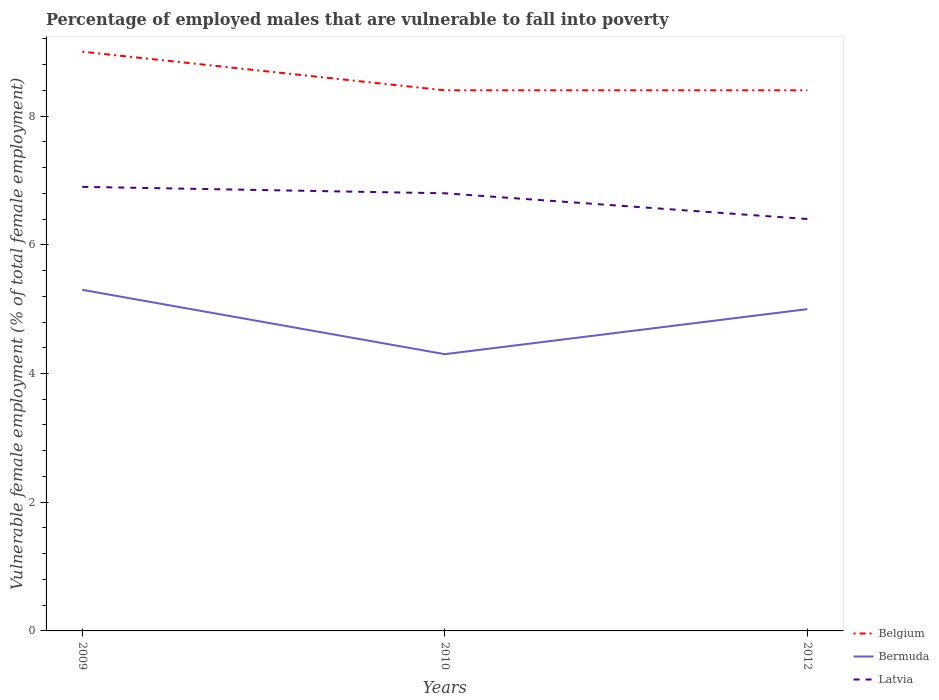Does the line corresponding to Bermuda intersect with the line corresponding to Latvia?
Provide a succinct answer. No. Is the number of lines equal to the number of legend labels?
Make the answer very short. Yes. Across all years, what is the maximum percentage of employed males who are vulnerable to fall into poverty in Bermuda?
Provide a succinct answer. 4.3. What is the total percentage of employed males who are vulnerable to fall into poverty in Bermuda in the graph?
Your answer should be compact. 1. What is the difference between the highest and the second highest percentage of employed males who are vulnerable to fall into poverty in Belgium?
Offer a terse response. 0.6. What is the difference between the highest and the lowest percentage of employed males who are vulnerable to fall into poverty in Bermuda?
Your answer should be compact. 2. Is the percentage of employed males who are vulnerable to fall into poverty in Bermuda strictly greater than the percentage of employed males who are vulnerable to fall into poverty in Belgium over the years?
Make the answer very short. Yes. How many lines are there?
Make the answer very short. 3. How many years are there in the graph?
Keep it short and to the point. 3. Are the values on the major ticks of Y-axis written in scientific E-notation?
Offer a very short reply. No. Where does the legend appear in the graph?
Your response must be concise. Bottom right. How many legend labels are there?
Make the answer very short. 3. What is the title of the graph?
Your response must be concise. Percentage of employed males that are vulnerable to fall into poverty. Does "Trinidad and Tobago" appear as one of the legend labels in the graph?
Offer a very short reply. No. What is the label or title of the Y-axis?
Offer a terse response. Vulnerable female employment (% of total female employment). What is the Vulnerable female employment (% of total female employment) in Bermuda in 2009?
Offer a very short reply. 5.3. What is the Vulnerable female employment (% of total female employment) in Latvia in 2009?
Your answer should be very brief. 6.9. What is the Vulnerable female employment (% of total female employment) of Belgium in 2010?
Make the answer very short. 8.4. What is the Vulnerable female employment (% of total female employment) in Bermuda in 2010?
Make the answer very short. 4.3. What is the Vulnerable female employment (% of total female employment) in Latvia in 2010?
Give a very brief answer. 6.8. What is the Vulnerable female employment (% of total female employment) of Belgium in 2012?
Make the answer very short. 8.4. What is the Vulnerable female employment (% of total female employment) in Latvia in 2012?
Offer a very short reply. 6.4. Across all years, what is the maximum Vulnerable female employment (% of total female employment) of Belgium?
Provide a short and direct response. 9. Across all years, what is the maximum Vulnerable female employment (% of total female employment) of Bermuda?
Your answer should be very brief. 5.3. Across all years, what is the maximum Vulnerable female employment (% of total female employment) in Latvia?
Keep it short and to the point. 6.9. Across all years, what is the minimum Vulnerable female employment (% of total female employment) in Belgium?
Ensure brevity in your answer.  8.4. Across all years, what is the minimum Vulnerable female employment (% of total female employment) in Bermuda?
Offer a terse response. 4.3. Across all years, what is the minimum Vulnerable female employment (% of total female employment) in Latvia?
Your answer should be very brief. 6.4. What is the total Vulnerable female employment (% of total female employment) in Belgium in the graph?
Keep it short and to the point. 25.8. What is the total Vulnerable female employment (% of total female employment) of Bermuda in the graph?
Your response must be concise. 14.6. What is the total Vulnerable female employment (% of total female employment) in Latvia in the graph?
Your answer should be very brief. 20.1. What is the difference between the Vulnerable female employment (% of total female employment) in Latvia in 2009 and that in 2010?
Make the answer very short. 0.1. What is the difference between the Vulnerable female employment (% of total female employment) in Belgium in 2009 and that in 2012?
Your response must be concise. 0.6. What is the difference between the Vulnerable female employment (% of total female employment) in Bermuda in 2009 and that in 2012?
Your answer should be compact. 0.3. What is the difference between the Vulnerable female employment (% of total female employment) of Latvia in 2009 and that in 2012?
Provide a short and direct response. 0.5. What is the difference between the Vulnerable female employment (% of total female employment) in Belgium in 2010 and that in 2012?
Keep it short and to the point. 0. What is the difference between the Vulnerable female employment (% of total female employment) of Bermuda in 2010 and that in 2012?
Give a very brief answer. -0.7. What is the difference between the Vulnerable female employment (% of total female employment) of Latvia in 2010 and that in 2012?
Offer a terse response. 0.4. What is the difference between the Vulnerable female employment (% of total female employment) in Belgium in 2009 and the Vulnerable female employment (% of total female employment) in Latvia in 2010?
Offer a terse response. 2.2. What is the difference between the Vulnerable female employment (% of total female employment) in Bermuda in 2009 and the Vulnerable female employment (% of total female employment) in Latvia in 2010?
Give a very brief answer. -1.5. What is the difference between the Vulnerable female employment (% of total female employment) of Bermuda in 2009 and the Vulnerable female employment (% of total female employment) of Latvia in 2012?
Give a very brief answer. -1.1. What is the difference between the Vulnerable female employment (% of total female employment) in Bermuda in 2010 and the Vulnerable female employment (% of total female employment) in Latvia in 2012?
Provide a succinct answer. -2.1. What is the average Vulnerable female employment (% of total female employment) of Bermuda per year?
Ensure brevity in your answer.  4.87. What is the average Vulnerable female employment (% of total female employment) of Latvia per year?
Provide a succinct answer. 6.7. In the year 2009, what is the difference between the Vulnerable female employment (% of total female employment) in Belgium and Vulnerable female employment (% of total female employment) in Bermuda?
Give a very brief answer. 3.7. In the year 2010, what is the difference between the Vulnerable female employment (% of total female employment) of Belgium and Vulnerable female employment (% of total female employment) of Bermuda?
Your answer should be very brief. 4.1. In the year 2010, what is the difference between the Vulnerable female employment (% of total female employment) in Bermuda and Vulnerable female employment (% of total female employment) in Latvia?
Keep it short and to the point. -2.5. In the year 2012, what is the difference between the Vulnerable female employment (% of total female employment) in Belgium and Vulnerable female employment (% of total female employment) in Bermuda?
Offer a terse response. 3.4. What is the ratio of the Vulnerable female employment (% of total female employment) in Belgium in 2009 to that in 2010?
Provide a short and direct response. 1.07. What is the ratio of the Vulnerable female employment (% of total female employment) in Bermuda in 2009 to that in 2010?
Make the answer very short. 1.23. What is the ratio of the Vulnerable female employment (% of total female employment) in Latvia in 2009 to that in 2010?
Provide a short and direct response. 1.01. What is the ratio of the Vulnerable female employment (% of total female employment) in Belgium in 2009 to that in 2012?
Keep it short and to the point. 1.07. What is the ratio of the Vulnerable female employment (% of total female employment) of Bermuda in 2009 to that in 2012?
Give a very brief answer. 1.06. What is the ratio of the Vulnerable female employment (% of total female employment) of Latvia in 2009 to that in 2012?
Offer a terse response. 1.08. What is the ratio of the Vulnerable female employment (% of total female employment) of Belgium in 2010 to that in 2012?
Offer a very short reply. 1. What is the ratio of the Vulnerable female employment (% of total female employment) of Bermuda in 2010 to that in 2012?
Your response must be concise. 0.86. What is the difference between the highest and the second highest Vulnerable female employment (% of total female employment) in Bermuda?
Make the answer very short. 0.3. What is the difference between the highest and the second highest Vulnerable female employment (% of total female employment) in Latvia?
Offer a terse response. 0.1. What is the difference between the highest and the lowest Vulnerable female employment (% of total female employment) of Bermuda?
Offer a very short reply. 1. 